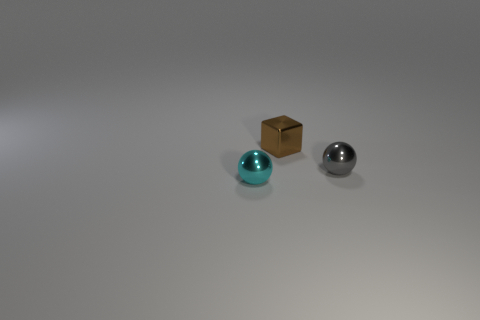Subtract all purple blocks. Subtract all cyan cylinders. How many blocks are left? 1 Subtract all brown cubes. How many green spheres are left? 0 Add 3 big purples. How many objects exist? 0 Subtract all yellow matte balls. Subtract all brown things. How many objects are left? 2 Add 1 brown things. How many brown things are left? 2 Add 1 tiny brown matte cubes. How many tiny brown matte cubes exist? 1 Add 1 small gray balls. How many objects exist? 4 Subtract all gray balls. How many balls are left? 1 Subtract 0 purple cylinders. How many objects are left? 3 Subtract all spheres. How many objects are left? 1 